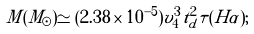<formula> <loc_0><loc_0><loc_500><loc_500>M ( M _ { \odot } ) \simeq ( 2 . 3 8 \times 1 0 ^ { - 5 } ) v _ { 4 } ^ { 3 } t _ { d } ^ { 2 } \tau ( H \alpha ) ;</formula> 